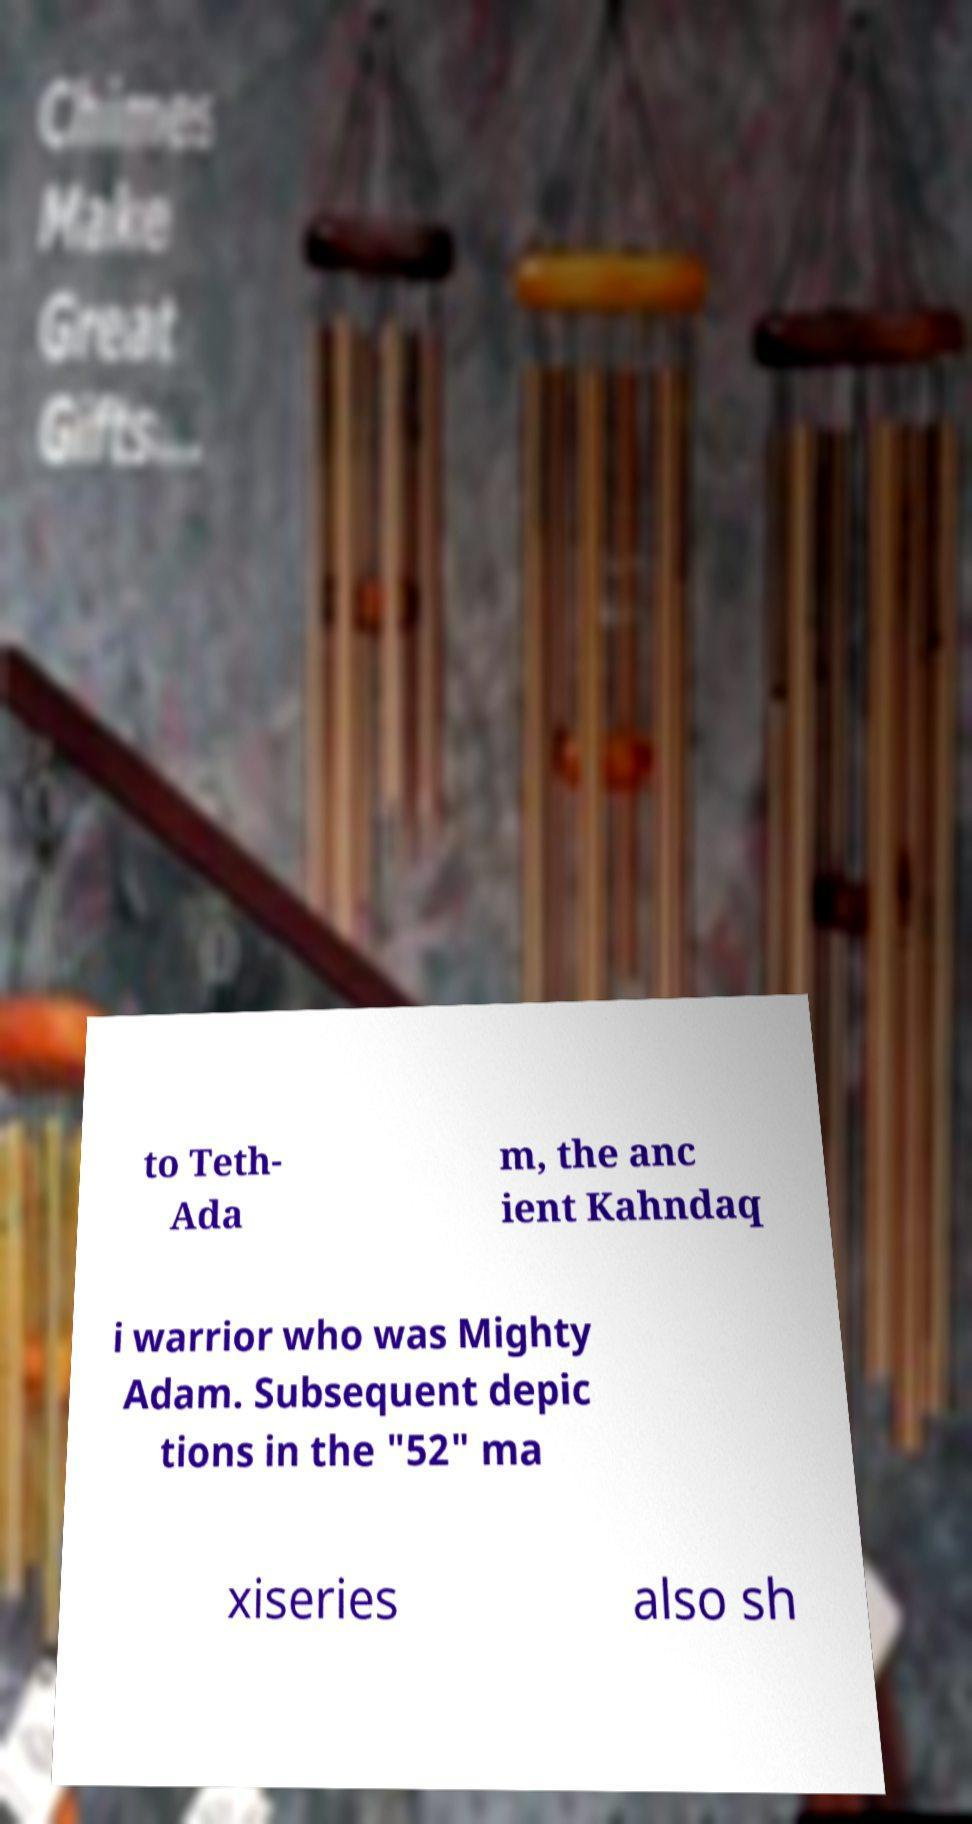Please identify and transcribe the text found in this image. to Teth- Ada m, the anc ient Kahndaq i warrior who was Mighty Adam. Subsequent depic tions in the "52" ma xiseries also sh 